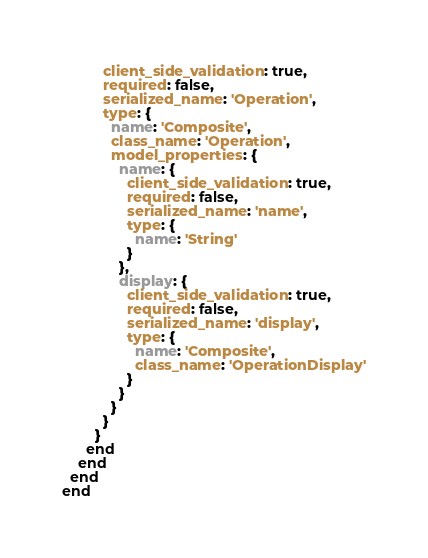<code> <loc_0><loc_0><loc_500><loc_500><_Ruby_>          client_side_validation: true,
          required: false,
          serialized_name: 'Operation',
          type: {
            name: 'Composite',
            class_name: 'Operation',
            model_properties: {
              name: {
                client_side_validation: true,
                required: false,
                serialized_name: 'name',
                type: {
                  name: 'String'
                }
              },
              display: {
                client_side_validation: true,
                required: false,
                serialized_name: 'display',
                type: {
                  name: 'Composite',
                  class_name: 'OperationDisplay'
                }
              }
            }
          }
        }
      end
    end
  end
end
</code> 